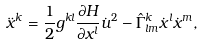<formula> <loc_0><loc_0><loc_500><loc_500>\ddot { x } ^ { k } = \frac { 1 } { 2 } g ^ { k l } \frac { \partial H } { \partial x ^ { l } } \dot { u } ^ { 2 } - { \hat { \Gamma } ^ { k } } _ { l m } \dot { x } ^ { l } \dot { x } ^ { m } ,</formula> 